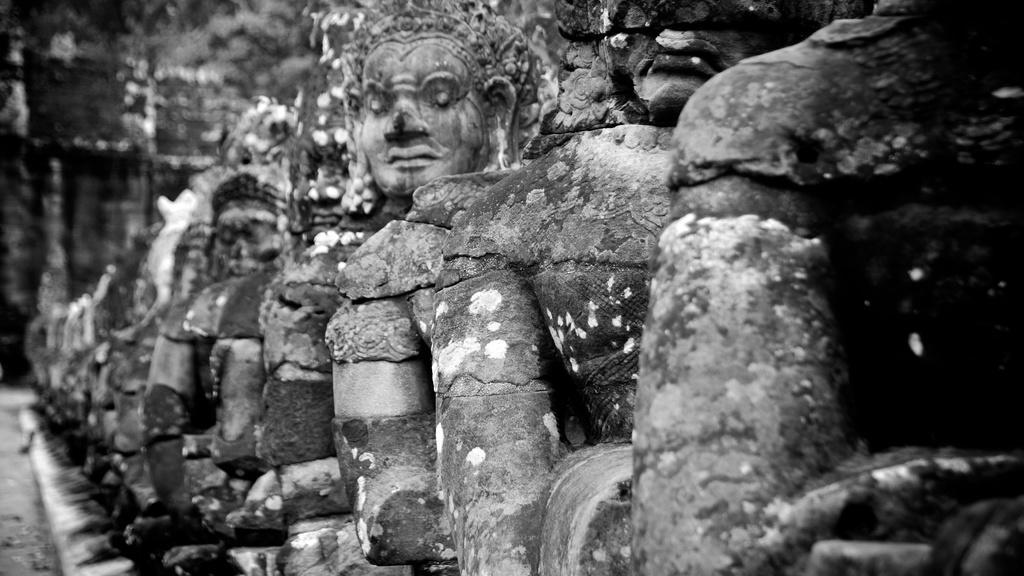Please provide a concise description of this image. In this picture we can see some sculptures, there is a blurry background, it is a black and white image. 